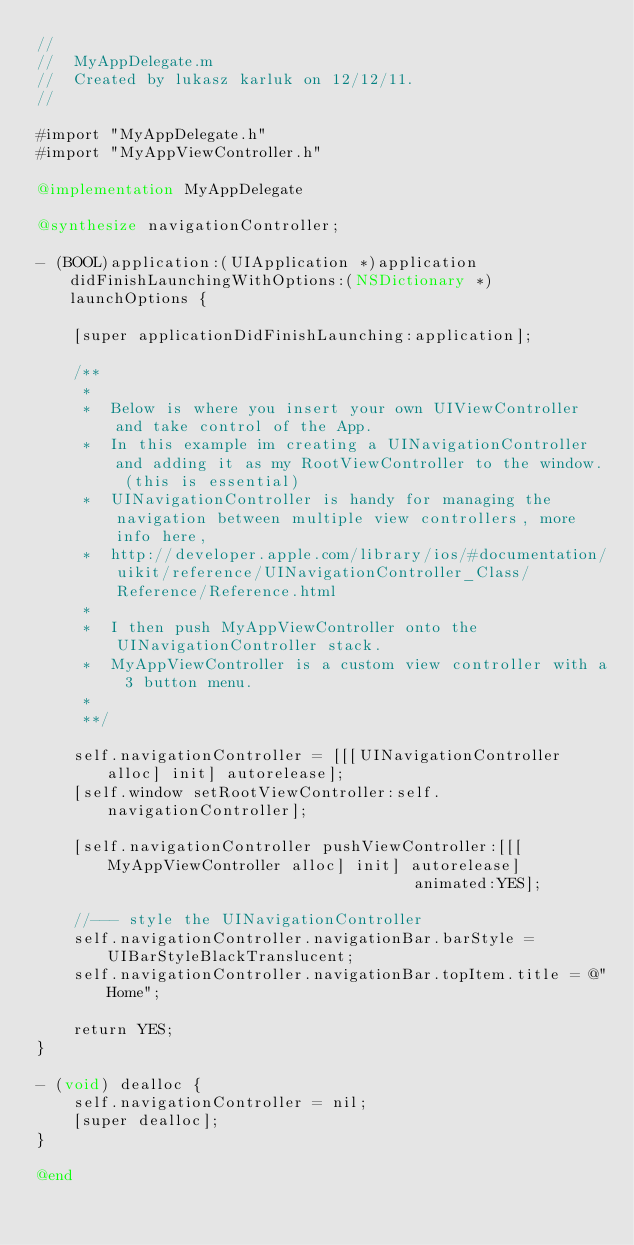<code> <loc_0><loc_0><loc_500><loc_500><_ObjectiveC_>//
//  MyAppDelegate.m
//  Created by lukasz karluk on 12/12/11.
//

#import "MyAppDelegate.h"
#import "MyAppViewController.h"

@implementation MyAppDelegate

@synthesize navigationController;

- (BOOL)application:(UIApplication *)application didFinishLaunchingWithOptions:(NSDictionary *)launchOptions {
    
    [super applicationDidFinishLaunching:application];
    
    /**
     *
     *  Below is where you insert your own UIViewController and take control of the App.
     *  In this example im creating a UINavigationController and adding it as my RootViewController to the window. (this is essential)
     *  UINavigationController is handy for managing the navigation between multiple view controllers, more info here,
     *  http://developer.apple.com/library/ios/#documentation/uikit/reference/UINavigationController_Class/Reference/Reference.html
     *
     *  I then push MyAppViewController onto the UINavigationController stack.
     *  MyAppViewController is a custom view controller with a 3 button menu.
     *
     **/
    
    self.navigationController = [[[UINavigationController alloc] init] autorelease];
    [self.window setRootViewController:self.navigationController];
    
    [self.navigationController pushViewController:[[[MyAppViewController alloc] init] autorelease]
                                         animated:YES];
    
    //--- style the UINavigationController
    self.navigationController.navigationBar.barStyle = UIBarStyleBlackTranslucent;
    self.navigationController.navigationBar.topItem.title = @"Home";
    
    return YES;
}

- (void) dealloc {
    self.navigationController = nil;
    [super dealloc];
}

@end
</code> 